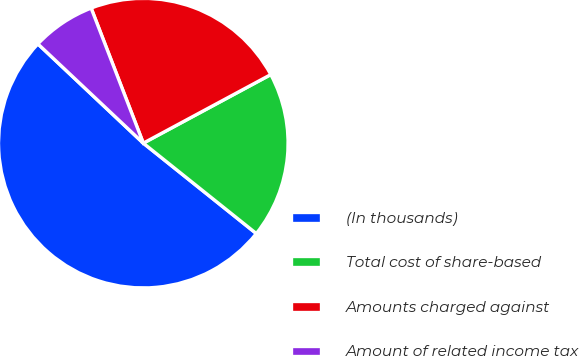Convert chart to OTSL. <chart><loc_0><loc_0><loc_500><loc_500><pie_chart><fcel>(In thousands)<fcel>Total cost of share-based<fcel>Amounts charged against<fcel>Amount of related income tax<nl><fcel>51.28%<fcel>18.59%<fcel>23.01%<fcel>7.11%<nl></chart> 